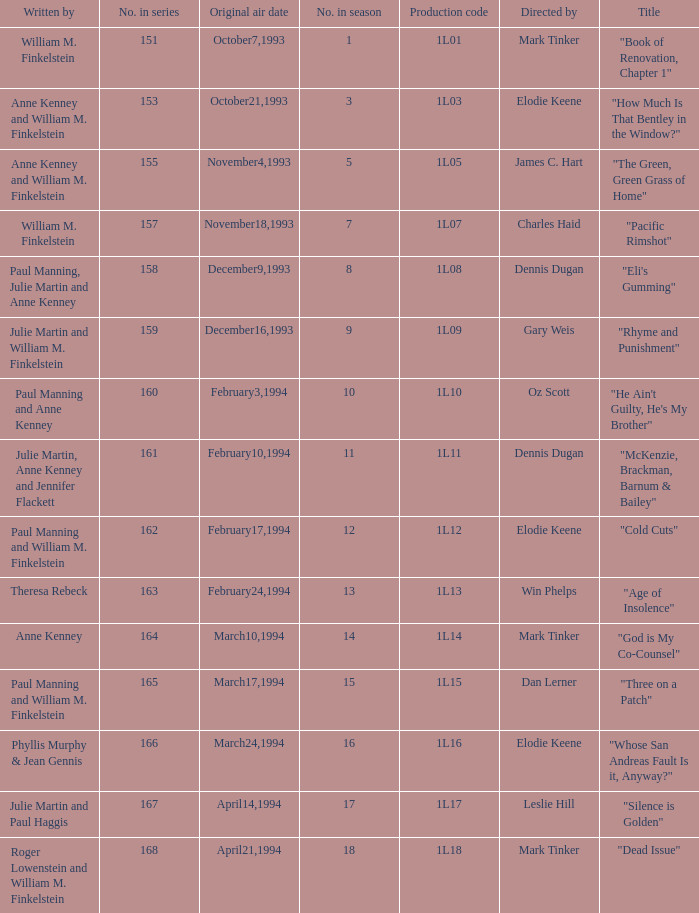Name who directed the production code 1l10 Oz Scott. 